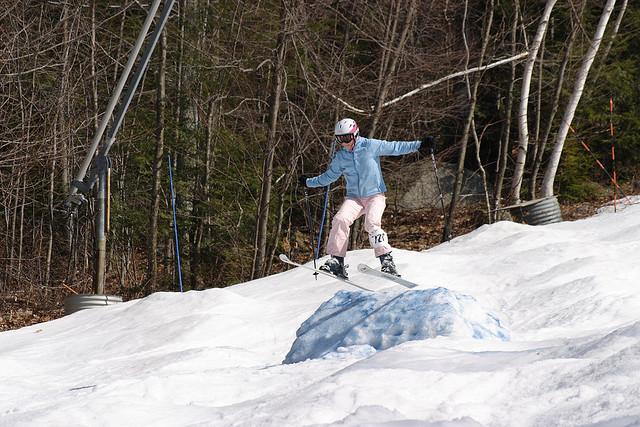Is the temperature below 32 Fahrenheit?
Write a very short answer. Yes. What color is their helmet?
Short answer required. White. What is the person in this scene doing?
Answer briefly. Skiing. 